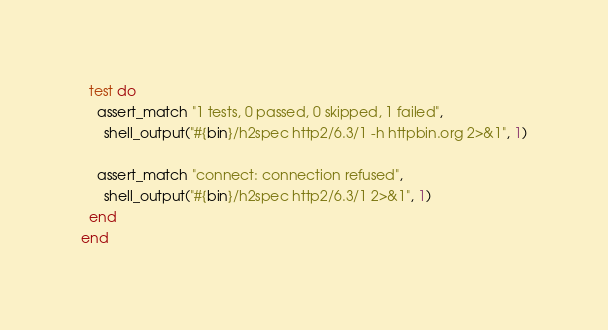Convert code to text. <code><loc_0><loc_0><loc_500><loc_500><_Ruby_>  test do
    assert_match "1 tests, 0 passed, 0 skipped, 1 failed",
      shell_output("#{bin}/h2spec http2/6.3/1 -h httpbin.org 2>&1", 1)

    assert_match "connect: connection refused",
      shell_output("#{bin}/h2spec http2/6.3/1 2>&1", 1)
  end
end
</code> 